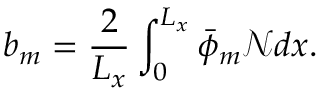Convert formula to latex. <formula><loc_0><loc_0><loc_500><loc_500>b _ { m } = \frac { 2 } { L _ { x } } \int _ { 0 } ^ { L _ { x } } \bar { \phi } _ { m } \mathcal { N } d x .</formula> 